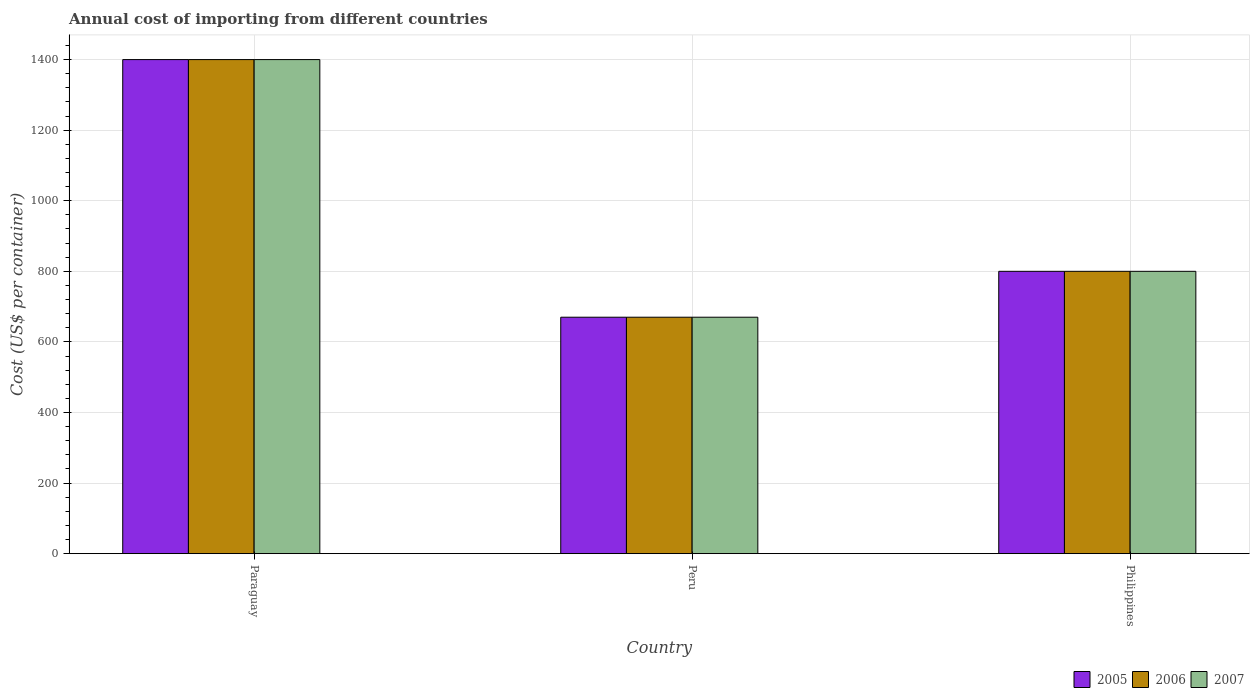How many different coloured bars are there?
Offer a very short reply. 3. How many bars are there on the 1st tick from the left?
Provide a short and direct response. 3. How many bars are there on the 3rd tick from the right?
Provide a short and direct response. 3. What is the label of the 3rd group of bars from the left?
Ensure brevity in your answer.  Philippines. What is the total annual cost of importing in 2005 in Philippines?
Provide a short and direct response. 800. Across all countries, what is the maximum total annual cost of importing in 2005?
Offer a very short reply. 1400. Across all countries, what is the minimum total annual cost of importing in 2007?
Ensure brevity in your answer.  670. In which country was the total annual cost of importing in 2006 maximum?
Offer a very short reply. Paraguay. In which country was the total annual cost of importing in 2005 minimum?
Provide a short and direct response. Peru. What is the total total annual cost of importing in 2007 in the graph?
Make the answer very short. 2870. What is the difference between the total annual cost of importing in 2006 in Peru and that in Philippines?
Give a very brief answer. -130. What is the difference between the total annual cost of importing in 2007 in Paraguay and the total annual cost of importing in 2006 in Philippines?
Your response must be concise. 600. What is the average total annual cost of importing in 2007 per country?
Your answer should be very brief. 956.67. What is the difference between the total annual cost of importing of/in 2007 and total annual cost of importing of/in 2005 in Philippines?
Provide a short and direct response. 0. What is the difference between the highest and the second highest total annual cost of importing in 2005?
Provide a succinct answer. 600. What is the difference between the highest and the lowest total annual cost of importing in 2007?
Provide a short and direct response. 730. Is the sum of the total annual cost of importing in 2007 in Peru and Philippines greater than the maximum total annual cost of importing in 2005 across all countries?
Give a very brief answer. Yes. What does the 2nd bar from the right in Philippines represents?
Offer a very short reply. 2006. Is it the case that in every country, the sum of the total annual cost of importing in 2005 and total annual cost of importing in 2007 is greater than the total annual cost of importing in 2006?
Offer a terse response. Yes. How many bars are there?
Ensure brevity in your answer.  9. Are all the bars in the graph horizontal?
Ensure brevity in your answer.  No. What is the difference between two consecutive major ticks on the Y-axis?
Ensure brevity in your answer.  200. Does the graph contain any zero values?
Provide a short and direct response. No. Where does the legend appear in the graph?
Ensure brevity in your answer.  Bottom right. How are the legend labels stacked?
Make the answer very short. Horizontal. What is the title of the graph?
Your answer should be compact. Annual cost of importing from different countries. What is the label or title of the Y-axis?
Give a very brief answer. Cost (US$ per container). What is the Cost (US$ per container) in 2005 in Paraguay?
Provide a short and direct response. 1400. What is the Cost (US$ per container) of 2006 in Paraguay?
Ensure brevity in your answer.  1400. What is the Cost (US$ per container) of 2007 in Paraguay?
Ensure brevity in your answer.  1400. What is the Cost (US$ per container) of 2005 in Peru?
Your response must be concise. 670. What is the Cost (US$ per container) in 2006 in Peru?
Your answer should be very brief. 670. What is the Cost (US$ per container) in 2007 in Peru?
Ensure brevity in your answer.  670. What is the Cost (US$ per container) in 2005 in Philippines?
Ensure brevity in your answer.  800. What is the Cost (US$ per container) in 2006 in Philippines?
Your response must be concise. 800. What is the Cost (US$ per container) of 2007 in Philippines?
Provide a succinct answer. 800. Across all countries, what is the maximum Cost (US$ per container) in 2005?
Keep it short and to the point. 1400. Across all countries, what is the maximum Cost (US$ per container) in 2006?
Your response must be concise. 1400. Across all countries, what is the maximum Cost (US$ per container) of 2007?
Provide a succinct answer. 1400. Across all countries, what is the minimum Cost (US$ per container) in 2005?
Your response must be concise. 670. Across all countries, what is the minimum Cost (US$ per container) of 2006?
Provide a succinct answer. 670. Across all countries, what is the minimum Cost (US$ per container) of 2007?
Provide a succinct answer. 670. What is the total Cost (US$ per container) of 2005 in the graph?
Provide a short and direct response. 2870. What is the total Cost (US$ per container) in 2006 in the graph?
Provide a succinct answer. 2870. What is the total Cost (US$ per container) of 2007 in the graph?
Your answer should be very brief. 2870. What is the difference between the Cost (US$ per container) in 2005 in Paraguay and that in Peru?
Provide a short and direct response. 730. What is the difference between the Cost (US$ per container) of 2006 in Paraguay and that in Peru?
Provide a succinct answer. 730. What is the difference between the Cost (US$ per container) of 2007 in Paraguay and that in Peru?
Make the answer very short. 730. What is the difference between the Cost (US$ per container) of 2005 in Paraguay and that in Philippines?
Your answer should be very brief. 600. What is the difference between the Cost (US$ per container) in 2006 in Paraguay and that in Philippines?
Ensure brevity in your answer.  600. What is the difference between the Cost (US$ per container) of 2007 in Paraguay and that in Philippines?
Your answer should be very brief. 600. What is the difference between the Cost (US$ per container) in 2005 in Peru and that in Philippines?
Your answer should be compact. -130. What is the difference between the Cost (US$ per container) of 2006 in Peru and that in Philippines?
Offer a very short reply. -130. What is the difference between the Cost (US$ per container) in 2007 in Peru and that in Philippines?
Give a very brief answer. -130. What is the difference between the Cost (US$ per container) in 2005 in Paraguay and the Cost (US$ per container) in 2006 in Peru?
Keep it short and to the point. 730. What is the difference between the Cost (US$ per container) in 2005 in Paraguay and the Cost (US$ per container) in 2007 in Peru?
Your response must be concise. 730. What is the difference between the Cost (US$ per container) of 2006 in Paraguay and the Cost (US$ per container) of 2007 in Peru?
Provide a succinct answer. 730. What is the difference between the Cost (US$ per container) in 2005 in Paraguay and the Cost (US$ per container) in 2006 in Philippines?
Offer a terse response. 600. What is the difference between the Cost (US$ per container) of 2005 in Paraguay and the Cost (US$ per container) of 2007 in Philippines?
Your answer should be very brief. 600. What is the difference between the Cost (US$ per container) of 2006 in Paraguay and the Cost (US$ per container) of 2007 in Philippines?
Provide a succinct answer. 600. What is the difference between the Cost (US$ per container) of 2005 in Peru and the Cost (US$ per container) of 2006 in Philippines?
Your answer should be compact. -130. What is the difference between the Cost (US$ per container) in 2005 in Peru and the Cost (US$ per container) in 2007 in Philippines?
Offer a very short reply. -130. What is the difference between the Cost (US$ per container) of 2006 in Peru and the Cost (US$ per container) of 2007 in Philippines?
Your answer should be very brief. -130. What is the average Cost (US$ per container) of 2005 per country?
Your response must be concise. 956.67. What is the average Cost (US$ per container) in 2006 per country?
Offer a terse response. 956.67. What is the average Cost (US$ per container) of 2007 per country?
Your answer should be very brief. 956.67. What is the difference between the Cost (US$ per container) of 2005 and Cost (US$ per container) of 2007 in Paraguay?
Offer a very short reply. 0. What is the difference between the Cost (US$ per container) of 2005 and Cost (US$ per container) of 2007 in Philippines?
Your response must be concise. 0. What is the ratio of the Cost (US$ per container) in 2005 in Paraguay to that in Peru?
Your answer should be very brief. 2.09. What is the ratio of the Cost (US$ per container) in 2006 in Paraguay to that in Peru?
Keep it short and to the point. 2.09. What is the ratio of the Cost (US$ per container) of 2007 in Paraguay to that in Peru?
Make the answer very short. 2.09. What is the ratio of the Cost (US$ per container) in 2006 in Paraguay to that in Philippines?
Provide a succinct answer. 1.75. What is the ratio of the Cost (US$ per container) of 2005 in Peru to that in Philippines?
Offer a very short reply. 0.84. What is the ratio of the Cost (US$ per container) of 2006 in Peru to that in Philippines?
Give a very brief answer. 0.84. What is the ratio of the Cost (US$ per container) of 2007 in Peru to that in Philippines?
Keep it short and to the point. 0.84. What is the difference between the highest and the second highest Cost (US$ per container) of 2005?
Offer a terse response. 600. What is the difference between the highest and the second highest Cost (US$ per container) in 2006?
Provide a succinct answer. 600. What is the difference between the highest and the second highest Cost (US$ per container) of 2007?
Provide a short and direct response. 600. What is the difference between the highest and the lowest Cost (US$ per container) in 2005?
Offer a terse response. 730. What is the difference between the highest and the lowest Cost (US$ per container) of 2006?
Your answer should be very brief. 730. What is the difference between the highest and the lowest Cost (US$ per container) of 2007?
Offer a very short reply. 730. 